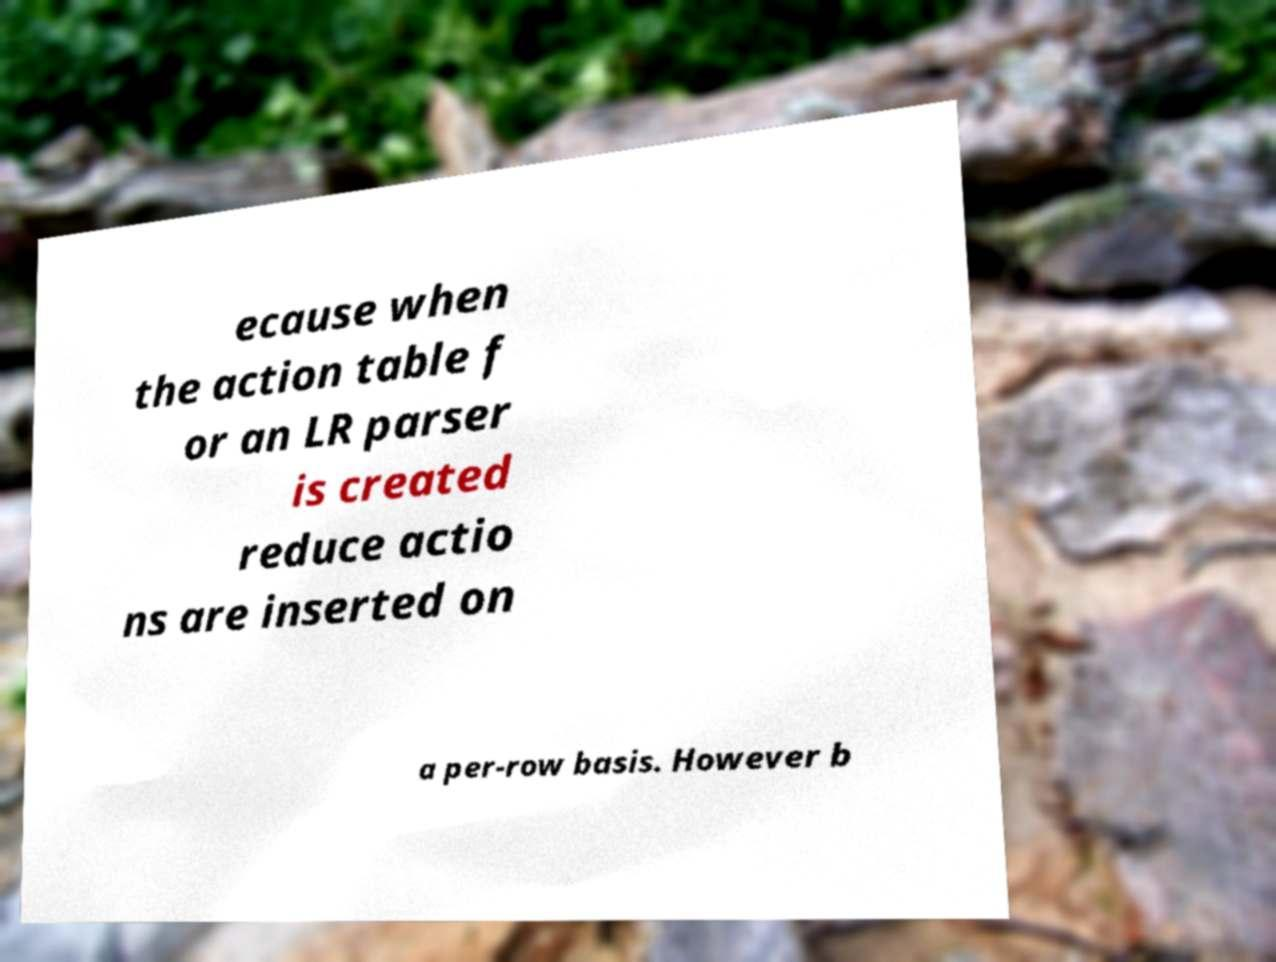Could you assist in decoding the text presented in this image and type it out clearly? ecause when the action table f or an LR parser is created reduce actio ns are inserted on a per-row basis. However b 